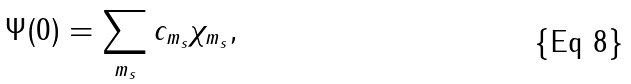<formula> <loc_0><loc_0><loc_500><loc_500>\Psi ( 0 ) = \sum _ { m _ { s } } c _ { m _ { s } } \chi _ { m _ { s } } ,</formula> 